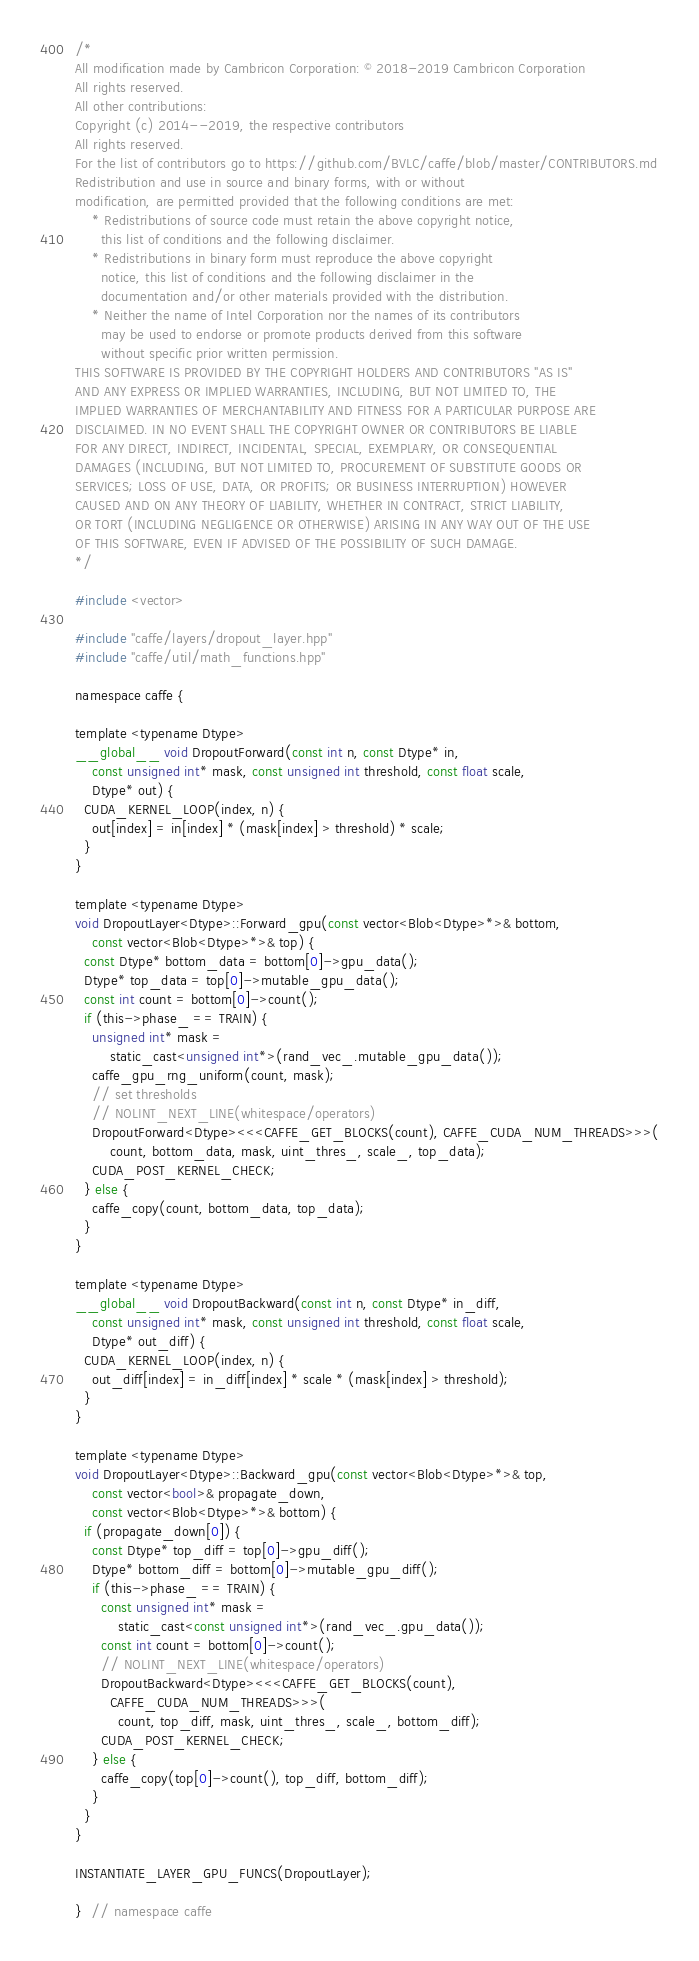<code> <loc_0><loc_0><loc_500><loc_500><_Cuda_>/*
All modification made by Cambricon Corporation: © 2018-2019 Cambricon Corporation
All rights reserved.
All other contributions:
Copyright (c) 2014--2019, the respective contributors
All rights reserved.
For the list of contributors go to https://github.com/BVLC/caffe/blob/master/CONTRIBUTORS.md
Redistribution and use in source and binary forms, with or without
modification, are permitted provided that the following conditions are met:
    * Redistributions of source code must retain the above copyright notice,
      this list of conditions and the following disclaimer.
    * Redistributions in binary form must reproduce the above copyright
      notice, this list of conditions and the following disclaimer in the
      documentation and/or other materials provided with the distribution.
    * Neither the name of Intel Corporation nor the names of its contributors
      may be used to endorse or promote products derived from this software
      without specific prior written permission.
THIS SOFTWARE IS PROVIDED BY THE COPYRIGHT HOLDERS AND CONTRIBUTORS "AS IS"
AND ANY EXPRESS OR IMPLIED WARRANTIES, INCLUDING, BUT NOT LIMITED TO, THE
IMPLIED WARRANTIES OF MERCHANTABILITY AND FITNESS FOR A PARTICULAR PURPOSE ARE
DISCLAIMED. IN NO EVENT SHALL THE COPYRIGHT OWNER OR CONTRIBUTORS BE LIABLE
FOR ANY DIRECT, INDIRECT, INCIDENTAL, SPECIAL, EXEMPLARY, OR CONSEQUENTIAL
DAMAGES (INCLUDING, BUT NOT LIMITED TO, PROCUREMENT OF SUBSTITUTE GOODS OR
SERVICES; LOSS OF USE, DATA, OR PROFITS; OR BUSINESS INTERRUPTION) HOWEVER
CAUSED AND ON ANY THEORY OF LIABILITY, WHETHER IN CONTRACT, STRICT LIABILITY,
OR TORT (INCLUDING NEGLIGENCE OR OTHERWISE) ARISING IN ANY WAY OUT OF THE USE
OF THIS SOFTWARE, EVEN IF ADVISED OF THE POSSIBILITY OF SUCH DAMAGE.
*/

#include <vector>

#include "caffe/layers/dropout_layer.hpp"
#include "caffe/util/math_functions.hpp"

namespace caffe {

template <typename Dtype>
__global__ void DropoutForward(const int n, const Dtype* in,
    const unsigned int* mask, const unsigned int threshold, const float scale,
    Dtype* out) {
  CUDA_KERNEL_LOOP(index, n) {
    out[index] = in[index] * (mask[index] > threshold) * scale;
  }
}

template <typename Dtype>
void DropoutLayer<Dtype>::Forward_gpu(const vector<Blob<Dtype>*>& bottom,
    const vector<Blob<Dtype>*>& top) {
  const Dtype* bottom_data = bottom[0]->gpu_data();
  Dtype* top_data = top[0]->mutable_gpu_data();
  const int count = bottom[0]->count();
  if (this->phase_ == TRAIN) {
    unsigned int* mask =
        static_cast<unsigned int*>(rand_vec_.mutable_gpu_data());
    caffe_gpu_rng_uniform(count, mask);
    // set thresholds
    // NOLINT_NEXT_LINE(whitespace/operators)
    DropoutForward<Dtype><<<CAFFE_GET_BLOCKS(count), CAFFE_CUDA_NUM_THREADS>>>(
        count, bottom_data, mask, uint_thres_, scale_, top_data);
    CUDA_POST_KERNEL_CHECK;
  } else {
    caffe_copy(count, bottom_data, top_data);
  }
}

template <typename Dtype>
__global__ void DropoutBackward(const int n, const Dtype* in_diff,
    const unsigned int* mask, const unsigned int threshold, const float scale,
    Dtype* out_diff) {
  CUDA_KERNEL_LOOP(index, n) {
    out_diff[index] = in_diff[index] * scale * (mask[index] > threshold);
  }
}

template <typename Dtype>
void DropoutLayer<Dtype>::Backward_gpu(const vector<Blob<Dtype>*>& top,
    const vector<bool>& propagate_down,
    const vector<Blob<Dtype>*>& bottom) {
  if (propagate_down[0]) {
    const Dtype* top_diff = top[0]->gpu_diff();
    Dtype* bottom_diff = bottom[0]->mutable_gpu_diff();
    if (this->phase_ == TRAIN) {
      const unsigned int* mask =
          static_cast<const unsigned int*>(rand_vec_.gpu_data());
      const int count = bottom[0]->count();
      // NOLINT_NEXT_LINE(whitespace/operators)
      DropoutBackward<Dtype><<<CAFFE_GET_BLOCKS(count),
        CAFFE_CUDA_NUM_THREADS>>>(
          count, top_diff, mask, uint_thres_, scale_, bottom_diff);
      CUDA_POST_KERNEL_CHECK;
    } else {
      caffe_copy(top[0]->count(), top_diff, bottom_diff);
    }
  }
}

INSTANTIATE_LAYER_GPU_FUNCS(DropoutLayer);

}  // namespace caffe
</code> 